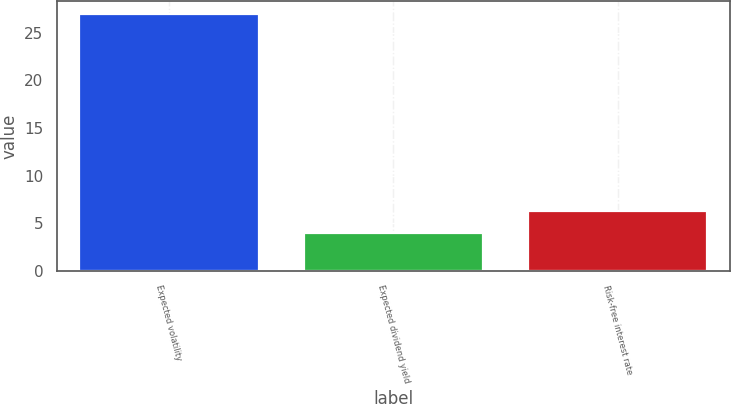Convert chart. <chart><loc_0><loc_0><loc_500><loc_500><bar_chart><fcel>Expected volatility<fcel>Expected dividend yield<fcel>Risk-free interest rate<nl><fcel>27<fcel>3.98<fcel>6.28<nl></chart> 